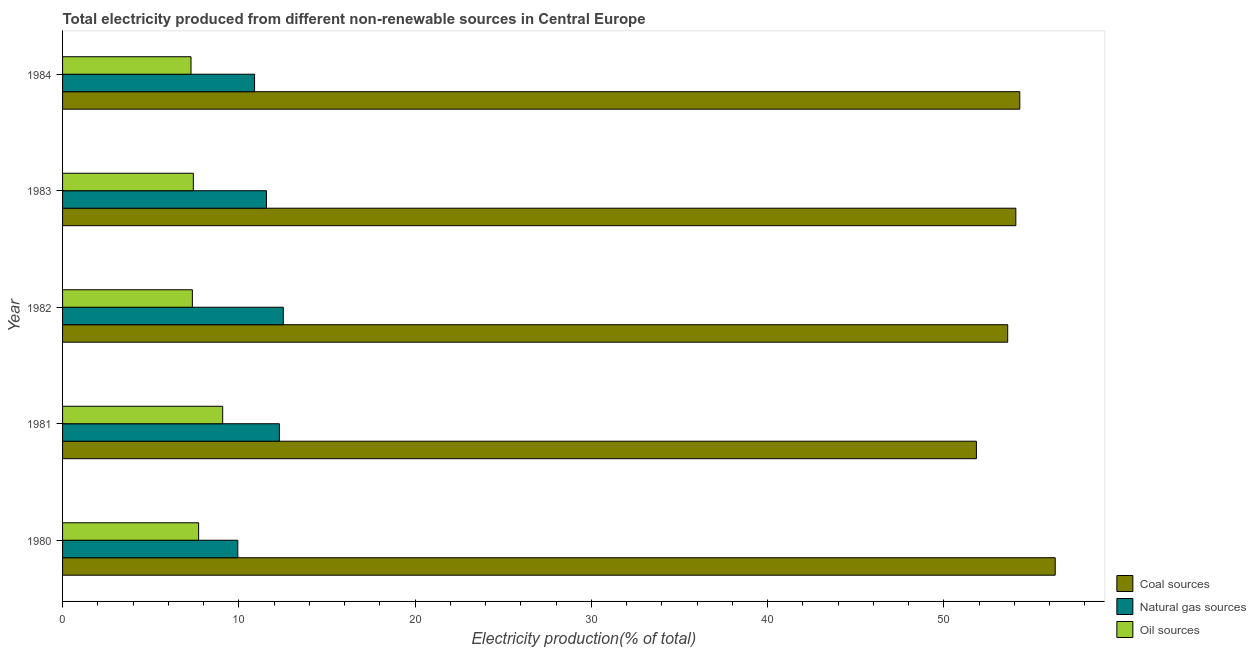How many different coloured bars are there?
Make the answer very short. 3. Are the number of bars per tick equal to the number of legend labels?
Your response must be concise. Yes. How many bars are there on the 5th tick from the top?
Your answer should be very brief. 3. How many bars are there on the 3rd tick from the bottom?
Offer a very short reply. 3. What is the label of the 5th group of bars from the top?
Offer a terse response. 1980. What is the percentage of electricity produced by coal in 1980?
Give a very brief answer. 56.32. Across all years, what is the maximum percentage of electricity produced by natural gas?
Offer a very short reply. 12.52. Across all years, what is the minimum percentage of electricity produced by coal?
Your response must be concise. 51.85. In which year was the percentage of electricity produced by coal maximum?
Offer a terse response. 1980. In which year was the percentage of electricity produced by coal minimum?
Provide a succinct answer. 1981. What is the total percentage of electricity produced by natural gas in the graph?
Your answer should be very brief. 57.24. What is the difference between the percentage of electricity produced by coal in 1982 and that in 1984?
Offer a terse response. -0.69. What is the difference between the percentage of electricity produced by natural gas in 1980 and the percentage of electricity produced by coal in 1982?
Provide a succinct answer. -43.69. What is the average percentage of electricity produced by oil sources per year?
Ensure brevity in your answer.  7.78. In the year 1983, what is the difference between the percentage of electricity produced by coal and percentage of electricity produced by oil sources?
Ensure brevity in your answer.  46.67. In how many years, is the percentage of electricity produced by coal greater than 42 %?
Offer a terse response. 5. What is the ratio of the percentage of electricity produced by coal in 1980 to that in 1981?
Your answer should be compact. 1.09. Is the difference between the percentage of electricity produced by coal in 1983 and 1984 greater than the difference between the percentage of electricity produced by oil sources in 1983 and 1984?
Your response must be concise. No. What is the difference between the highest and the second highest percentage of electricity produced by coal?
Offer a very short reply. 2.01. What is the difference between the highest and the lowest percentage of electricity produced by coal?
Give a very brief answer. 4.47. Is the sum of the percentage of electricity produced by natural gas in 1982 and 1984 greater than the maximum percentage of electricity produced by oil sources across all years?
Ensure brevity in your answer.  Yes. What does the 3rd bar from the top in 1980 represents?
Make the answer very short. Coal sources. What does the 1st bar from the bottom in 1984 represents?
Keep it short and to the point. Coal sources. Is it the case that in every year, the sum of the percentage of electricity produced by coal and percentage of electricity produced by natural gas is greater than the percentage of electricity produced by oil sources?
Give a very brief answer. Yes. How many years are there in the graph?
Offer a very short reply. 5. What is the difference between two consecutive major ticks on the X-axis?
Your answer should be very brief. 10. Does the graph contain grids?
Make the answer very short. No. Where does the legend appear in the graph?
Offer a terse response. Bottom right. What is the title of the graph?
Your response must be concise. Total electricity produced from different non-renewable sources in Central Europe. What is the Electricity production(% of total) in Coal sources in 1980?
Ensure brevity in your answer.  56.32. What is the Electricity production(% of total) of Natural gas sources in 1980?
Offer a very short reply. 9.94. What is the Electricity production(% of total) of Oil sources in 1980?
Give a very brief answer. 7.72. What is the Electricity production(% of total) of Coal sources in 1981?
Your response must be concise. 51.85. What is the Electricity production(% of total) of Natural gas sources in 1981?
Offer a very short reply. 12.3. What is the Electricity production(% of total) in Oil sources in 1981?
Keep it short and to the point. 9.09. What is the Electricity production(% of total) of Coal sources in 1982?
Your answer should be very brief. 53.63. What is the Electricity production(% of total) of Natural gas sources in 1982?
Your answer should be compact. 12.52. What is the Electricity production(% of total) of Oil sources in 1982?
Give a very brief answer. 7.36. What is the Electricity production(% of total) of Coal sources in 1983?
Keep it short and to the point. 54.09. What is the Electricity production(% of total) of Natural gas sources in 1983?
Provide a succinct answer. 11.57. What is the Electricity production(% of total) of Oil sources in 1983?
Provide a short and direct response. 7.42. What is the Electricity production(% of total) of Coal sources in 1984?
Your answer should be very brief. 54.31. What is the Electricity production(% of total) in Natural gas sources in 1984?
Offer a terse response. 10.9. What is the Electricity production(% of total) of Oil sources in 1984?
Make the answer very short. 7.29. Across all years, what is the maximum Electricity production(% of total) of Coal sources?
Make the answer very short. 56.32. Across all years, what is the maximum Electricity production(% of total) of Natural gas sources?
Provide a succinct answer. 12.52. Across all years, what is the maximum Electricity production(% of total) in Oil sources?
Your answer should be very brief. 9.09. Across all years, what is the minimum Electricity production(% of total) in Coal sources?
Ensure brevity in your answer.  51.85. Across all years, what is the minimum Electricity production(% of total) of Natural gas sources?
Offer a terse response. 9.94. Across all years, what is the minimum Electricity production(% of total) of Oil sources?
Ensure brevity in your answer.  7.29. What is the total Electricity production(% of total) in Coal sources in the graph?
Provide a short and direct response. 270.21. What is the total Electricity production(% of total) of Natural gas sources in the graph?
Your answer should be compact. 57.24. What is the total Electricity production(% of total) of Oil sources in the graph?
Your answer should be compact. 38.88. What is the difference between the Electricity production(% of total) in Coal sources in 1980 and that in 1981?
Your answer should be very brief. 4.47. What is the difference between the Electricity production(% of total) in Natural gas sources in 1980 and that in 1981?
Your response must be concise. -2.36. What is the difference between the Electricity production(% of total) in Oil sources in 1980 and that in 1981?
Your response must be concise. -1.37. What is the difference between the Electricity production(% of total) in Coal sources in 1980 and that in 1982?
Your answer should be compact. 2.7. What is the difference between the Electricity production(% of total) in Natural gas sources in 1980 and that in 1982?
Provide a short and direct response. -2.58. What is the difference between the Electricity production(% of total) in Oil sources in 1980 and that in 1982?
Keep it short and to the point. 0.36. What is the difference between the Electricity production(% of total) of Coal sources in 1980 and that in 1983?
Offer a very short reply. 2.23. What is the difference between the Electricity production(% of total) in Natural gas sources in 1980 and that in 1983?
Your response must be concise. -1.63. What is the difference between the Electricity production(% of total) in Oil sources in 1980 and that in 1983?
Keep it short and to the point. 0.3. What is the difference between the Electricity production(% of total) in Coal sources in 1980 and that in 1984?
Keep it short and to the point. 2.01. What is the difference between the Electricity production(% of total) of Natural gas sources in 1980 and that in 1984?
Provide a succinct answer. -0.95. What is the difference between the Electricity production(% of total) in Oil sources in 1980 and that in 1984?
Offer a very short reply. 0.43. What is the difference between the Electricity production(% of total) in Coal sources in 1981 and that in 1982?
Keep it short and to the point. -1.78. What is the difference between the Electricity production(% of total) of Natural gas sources in 1981 and that in 1982?
Offer a terse response. -0.22. What is the difference between the Electricity production(% of total) of Oil sources in 1981 and that in 1982?
Ensure brevity in your answer.  1.72. What is the difference between the Electricity production(% of total) in Coal sources in 1981 and that in 1983?
Your answer should be compact. -2.24. What is the difference between the Electricity production(% of total) of Natural gas sources in 1981 and that in 1983?
Keep it short and to the point. 0.73. What is the difference between the Electricity production(% of total) of Oil sources in 1981 and that in 1983?
Your answer should be very brief. 1.66. What is the difference between the Electricity production(% of total) in Coal sources in 1981 and that in 1984?
Offer a terse response. -2.46. What is the difference between the Electricity production(% of total) of Natural gas sources in 1981 and that in 1984?
Your response must be concise. 1.41. What is the difference between the Electricity production(% of total) of Oil sources in 1981 and that in 1984?
Your answer should be compact. 1.8. What is the difference between the Electricity production(% of total) of Coal sources in 1982 and that in 1983?
Your answer should be very brief. -0.46. What is the difference between the Electricity production(% of total) of Natural gas sources in 1982 and that in 1983?
Your response must be concise. 0.95. What is the difference between the Electricity production(% of total) in Oil sources in 1982 and that in 1983?
Ensure brevity in your answer.  -0.06. What is the difference between the Electricity production(% of total) in Coal sources in 1982 and that in 1984?
Your answer should be very brief. -0.69. What is the difference between the Electricity production(% of total) in Natural gas sources in 1982 and that in 1984?
Offer a terse response. 1.63. What is the difference between the Electricity production(% of total) in Oil sources in 1982 and that in 1984?
Give a very brief answer. 0.08. What is the difference between the Electricity production(% of total) in Coal sources in 1983 and that in 1984?
Offer a terse response. -0.22. What is the difference between the Electricity production(% of total) in Natural gas sources in 1983 and that in 1984?
Offer a very short reply. 0.67. What is the difference between the Electricity production(% of total) of Oil sources in 1983 and that in 1984?
Your answer should be very brief. 0.13. What is the difference between the Electricity production(% of total) of Coal sources in 1980 and the Electricity production(% of total) of Natural gas sources in 1981?
Offer a terse response. 44.02. What is the difference between the Electricity production(% of total) of Coal sources in 1980 and the Electricity production(% of total) of Oil sources in 1981?
Your response must be concise. 47.24. What is the difference between the Electricity production(% of total) in Natural gas sources in 1980 and the Electricity production(% of total) in Oil sources in 1981?
Your answer should be compact. 0.86. What is the difference between the Electricity production(% of total) of Coal sources in 1980 and the Electricity production(% of total) of Natural gas sources in 1982?
Provide a short and direct response. 43.8. What is the difference between the Electricity production(% of total) of Coal sources in 1980 and the Electricity production(% of total) of Oil sources in 1982?
Provide a succinct answer. 48.96. What is the difference between the Electricity production(% of total) in Natural gas sources in 1980 and the Electricity production(% of total) in Oil sources in 1982?
Offer a terse response. 2.58. What is the difference between the Electricity production(% of total) of Coal sources in 1980 and the Electricity production(% of total) of Natural gas sources in 1983?
Keep it short and to the point. 44.75. What is the difference between the Electricity production(% of total) of Coal sources in 1980 and the Electricity production(% of total) of Oil sources in 1983?
Make the answer very short. 48.9. What is the difference between the Electricity production(% of total) in Natural gas sources in 1980 and the Electricity production(% of total) in Oil sources in 1983?
Give a very brief answer. 2.52. What is the difference between the Electricity production(% of total) of Coal sources in 1980 and the Electricity production(% of total) of Natural gas sources in 1984?
Offer a very short reply. 45.43. What is the difference between the Electricity production(% of total) of Coal sources in 1980 and the Electricity production(% of total) of Oil sources in 1984?
Your answer should be very brief. 49.04. What is the difference between the Electricity production(% of total) in Natural gas sources in 1980 and the Electricity production(% of total) in Oil sources in 1984?
Give a very brief answer. 2.66. What is the difference between the Electricity production(% of total) of Coal sources in 1981 and the Electricity production(% of total) of Natural gas sources in 1982?
Your answer should be very brief. 39.33. What is the difference between the Electricity production(% of total) in Coal sources in 1981 and the Electricity production(% of total) in Oil sources in 1982?
Your response must be concise. 44.49. What is the difference between the Electricity production(% of total) in Natural gas sources in 1981 and the Electricity production(% of total) in Oil sources in 1982?
Offer a very short reply. 4.94. What is the difference between the Electricity production(% of total) of Coal sources in 1981 and the Electricity production(% of total) of Natural gas sources in 1983?
Your answer should be compact. 40.28. What is the difference between the Electricity production(% of total) of Coal sources in 1981 and the Electricity production(% of total) of Oil sources in 1983?
Provide a succinct answer. 44.43. What is the difference between the Electricity production(% of total) of Natural gas sources in 1981 and the Electricity production(% of total) of Oil sources in 1983?
Ensure brevity in your answer.  4.88. What is the difference between the Electricity production(% of total) in Coal sources in 1981 and the Electricity production(% of total) in Natural gas sources in 1984?
Provide a short and direct response. 40.96. What is the difference between the Electricity production(% of total) in Coal sources in 1981 and the Electricity production(% of total) in Oil sources in 1984?
Offer a terse response. 44.56. What is the difference between the Electricity production(% of total) in Natural gas sources in 1981 and the Electricity production(% of total) in Oil sources in 1984?
Ensure brevity in your answer.  5.02. What is the difference between the Electricity production(% of total) of Coal sources in 1982 and the Electricity production(% of total) of Natural gas sources in 1983?
Provide a succinct answer. 42.06. What is the difference between the Electricity production(% of total) of Coal sources in 1982 and the Electricity production(% of total) of Oil sources in 1983?
Your answer should be compact. 46.21. What is the difference between the Electricity production(% of total) of Natural gas sources in 1982 and the Electricity production(% of total) of Oil sources in 1983?
Keep it short and to the point. 5.1. What is the difference between the Electricity production(% of total) of Coal sources in 1982 and the Electricity production(% of total) of Natural gas sources in 1984?
Give a very brief answer. 42.73. What is the difference between the Electricity production(% of total) of Coal sources in 1982 and the Electricity production(% of total) of Oil sources in 1984?
Your answer should be very brief. 46.34. What is the difference between the Electricity production(% of total) of Natural gas sources in 1982 and the Electricity production(% of total) of Oil sources in 1984?
Offer a very short reply. 5.24. What is the difference between the Electricity production(% of total) in Coal sources in 1983 and the Electricity production(% of total) in Natural gas sources in 1984?
Keep it short and to the point. 43.2. What is the difference between the Electricity production(% of total) in Coal sources in 1983 and the Electricity production(% of total) in Oil sources in 1984?
Give a very brief answer. 46.8. What is the difference between the Electricity production(% of total) in Natural gas sources in 1983 and the Electricity production(% of total) in Oil sources in 1984?
Provide a succinct answer. 4.28. What is the average Electricity production(% of total) in Coal sources per year?
Your answer should be very brief. 54.04. What is the average Electricity production(% of total) of Natural gas sources per year?
Keep it short and to the point. 11.45. What is the average Electricity production(% of total) of Oil sources per year?
Your answer should be compact. 7.78. In the year 1980, what is the difference between the Electricity production(% of total) of Coal sources and Electricity production(% of total) of Natural gas sources?
Ensure brevity in your answer.  46.38. In the year 1980, what is the difference between the Electricity production(% of total) in Coal sources and Electricity production(% of total) in Oil sources?
Your answer should be very brief. 48.6. In the year 1980, what is the difference between the Electricity production(% of total) in Natural gas sources and Electricity production(% of total) in Oil sources?
Your answer should be compact. 2.22. In the year 1981, what is the difference between the Electricity production(% of total) in Coal sources and Electricity production(% of total) in Natural gas sources?
Provide a short and direct response. 39.55. In the year 1981, what is the difference between the Electricity production(% of total) of Coal sources and Electricity production(% of total) of Oil sources?
Offer a very short reply. 42.77. In the year 1981, what is the difference between the Electricity production(% of total) of Natural gas sources and Electricity production(% of total) of Oil sources?
Your answer should be very brief. 3.22. In the year 1982, what is the difference between the Electricity production(% of total) in Coal sources and Electricity production(% of total) in Natural gas sources?
Your response must be concise. 41.1. In the year 1982, what is the difference between the Electricity production(% of total) in Coal sources and Electricity production(% of total) in Oil sources?
Your answer should be compact. 46.26. In the year 1982, what is the difference between the Electricity production(% of total) of Natural gas sources and Electricity production(% of total) of Oil sources?
Offer a terse response. 5.16. In the year 1983, what is the difference between the Electricity production(% of total) in Coal sources and Electricity production(% of total) in Natural gas sources?
Provide a succinct answer. 42.52. In the year 1983, what is the difference between the Electricity production(% of total) of Coal sources and Electricity production(% of total) of Oil sources?
Keep it short and to the point. 46.67. In the year 1983, what is the difference between the Electricity production(% of total) in Natural gas sources and Electricity production(% of total) in Oil sources?
Give a very brief answer. 4.15. In the year 1984, what is the difference between the Electricity production(% of total) in Coal sources and Electricity production(% of total) in Natural gas sources?
Give a very brief answer. 43.42. In the year 1984, what is the difference between the Electricity production(% of total) in Coal sources and Electricity production(% of total) in Oil sources?
Your answer should be compact. 47.03. In the year 1984, what is the difference between the Electricity production(% of total) in Natural gas sources and Electricity production(% of total) in Oil sources?
Give a very brief answer. 3.61. What is the ratio of the Electricity production(% of total) in Coal sources in 1980 to that in 1981?
Your answer should be compact. 1.09. What is the ratio of the Electricity production(% of total) in Natural gas sources in 1980 to that in 1981?
Offer a terse response. 0.81. What is the ratio of the Electricity production(% of total) in Oil sources in 1980 to that in 1981?
Give a very brief answer. 0.85. What is the ratio of the Electricity production(% of total) of Coal sources in 1980 to that in 1982?
Your answer should be compact. 1.05. What is the ratio of the Electricity production(% of total) of Natural gas sources in 1980 to that in 1982?
Offer a very short reply. 0.79. What is the ratio of the Electricity production(% of total) in Oil sources in 1980 to that in 1982?
Provide a succinct answer. 1.05. What is the ratio of the Electricity production(% of total) in Coal sources in 1980 to that in 1983?
Keep it short and to the point. 1.04. What is the ratio of the Electricity production(% of total) in Natural gas sources in 1980 to that in 1983?
Provide a succinct answer. 0.86. What is the ratio of the Electricity production(% of total) in Oil sources in 1980 to that in 1983?
Offer a terse response. 1.04. What is the ratio of the Electricity production(% of total) in Coal sources in 1980 to that in 1984?
Your answer should be very brief. 1.04. What is the ratio of the Electricity production(% of total) in Natural gas sources in 1980 to that in 1984?
Offer a terse response. 0.91. What is the ratio of the Electricity production(% of total) in Oil sources in 1980 to that in 1984?
Keep it short and to the point. 1.06. What is the ratio of the Electricity production(% of total) of Coal sources in 1981 to that in 1982?
Your answer should be very brief. 0.97. What is the ratio of the Electricity production(% of total) in Natural gas sources in 1981 to that in 1982?
Give a very brief answer. 0.98. What is the ratio of the Electricity production(% of total) of Oil sources in 1981 to that in 1982?
Ensure brevity in your answer.  1.23. What is the ratio of the Electricity production(% of total) of Coal sources in 1981 to that in 1983?
Your answer should be compact. 0.96. What is the ratio of the Electricity production(% of total) of Natural gas sources in 1981 to that in 1983?
Offer a very short reply. 1.06. What is the ratio of the Electricity production(% of total) of Oil sources in 1981 to that in 1983?
Give a very brief answer. 1.22. What is the ratio of the Electricity production(% of total) in Coal sources in 1981 to that in 1984?
Keep it short and to the point. 0.95. What is the ratio of the Electricity production(% of total) in Natural gas sources in 1981 to that in 1984?
Make the answer very short. 1.13. What is the ratio of the Electricity production(% of total) of Oil sources in 1981 to that in 1984?
Offer a terse response. 1.25. What is the ratio of the Electricity production(% of total) in Natural gas sources in 1982 to that in 1983?
Offer a terse response. 1.08. What is the ratio of the Electricity production(% of total) in Oil sources in 1982 to that in 1983?
Offer a very short reply. 0.99. What is the ratio of the Electricity production(% of total) in Coal sources in 1982 to that in 1984?
Offer a terse response. 0.99. What is the ratio of the Electricity production(% of total) of Natural gas sources in 1982 to that in 1984?
Provide a succinct answer. 1.15. What is the ratio of the Electricity production(% of total) of Oil sources in 1982 to that in 1984?
Keep it short and to the point. 1.01. What is the ratio of the Electricity production(% of total) of Natural gas sources in 1983 to that in 1984?
Your response must be concise. 1.06. What is the ratio of the Electricity production(% of total) in Oil sources in 1983 to that in 1984?
Offer a terse response. 1.02. What is the difference between the highest and the second highest Electricity production(% of total) in Coal sources?
Make the answer very short. 2.01. What is the difference between the highest and the second highest Electricity production(% of total) of Natural gas sources?
Your response must be concise. 0.22. What is the difference between the highest and the second highest Electricity production(% of total) of Oil sources?
Ensure brevity in your answer.  1.37. What is the difference between the highest and the lowest Electricity production(% of total) in Coal sources?
Provide a short and direct response. 4.47. What is the difference between the highest and the lowest Electricity production(% of total) in Natural gas sources?
Your response must be concise. 2.58. What is the difference between the highest and the lowest Electricity production(% of total) in Oil sources?
Provide a short and direct response. 1.8. 